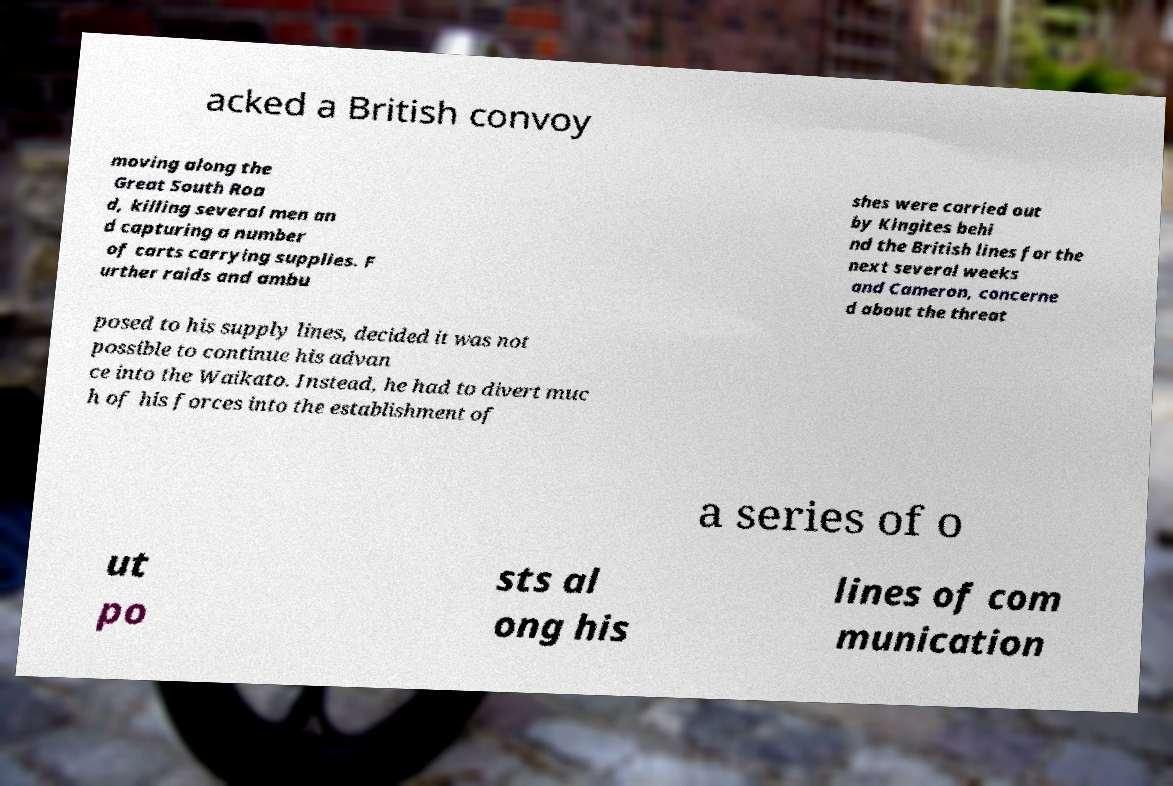Please identify and transcribe the text found in this image. acked a British convoy moving along the Great South Roa d, killing several men an d capturing a number of carts carrying supplies. F urther raids and ambu shes were carried out by Kingites behi nd the British lines for the next several weeks and Cameron, concerne d about the threat posed to his supply lines, decided it was not possible to continue his advan ce into the Waikato. Instead, he had to divert muc h of his forces into the establishment of a series of o ut po sts al ong his lines of com munication 